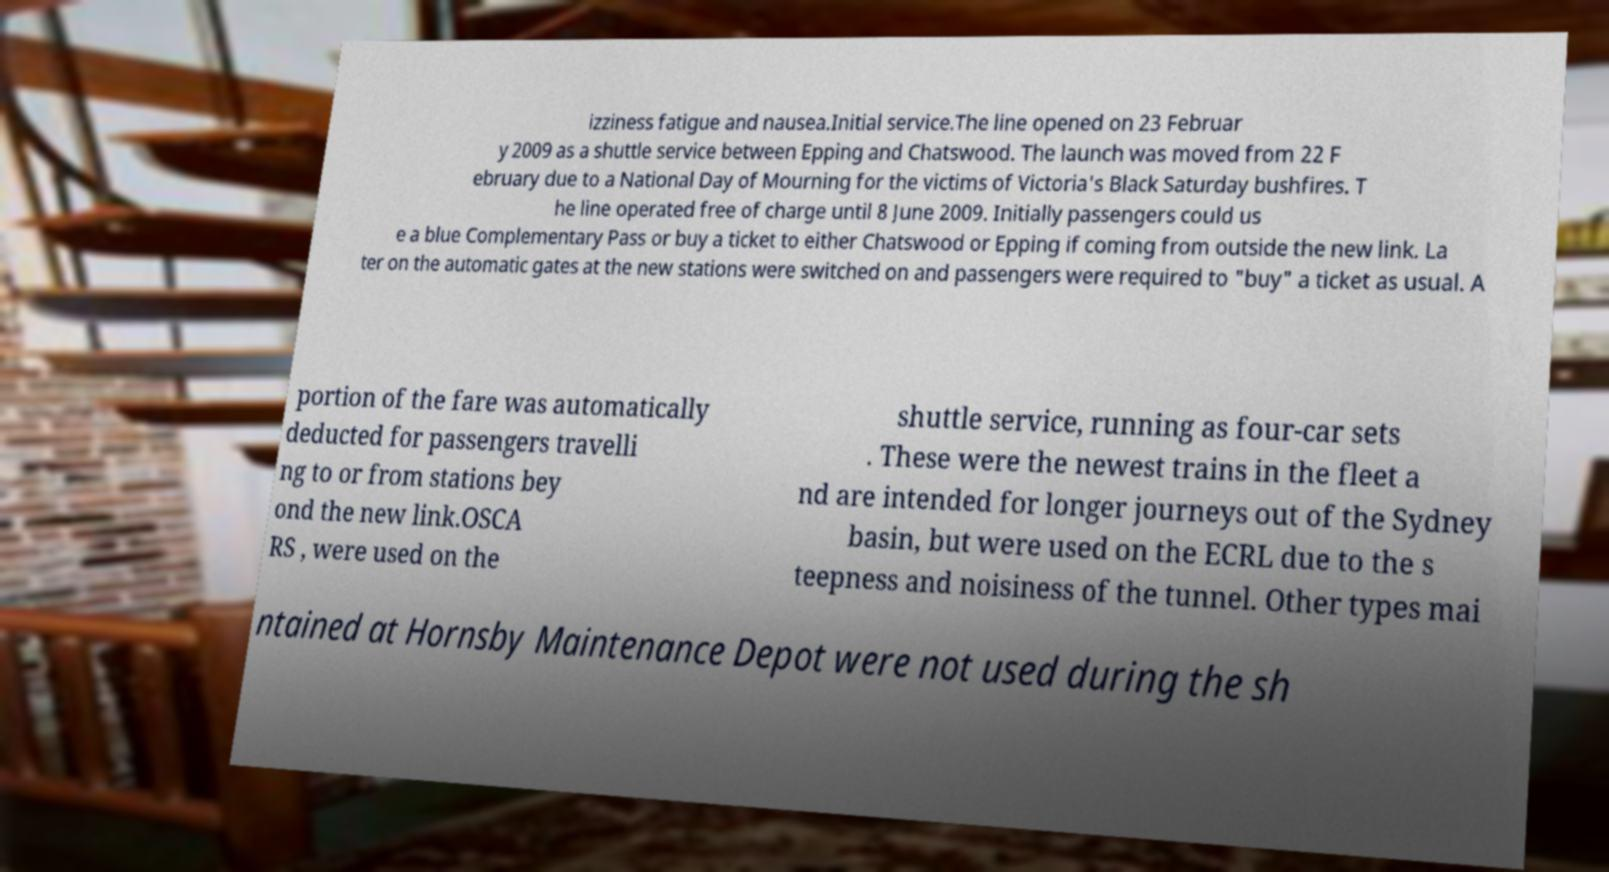Could you assist in decoding the text presented in this image and type it out clearly? izziness fatigue and nausea.Initial service.The line opened on 23 Februar y 2009 as a shuttle service between Epping and Chatswood. The launch was moved from 22 F ebruary due to a National Day of Mourning for the victims of Victoria's Black Saturday bushfires. T he line operated free of charge until 8 June 2009. Initially passengers could us e a blue Complementary Pass or buy a ticket to either Chatswood or Epping if coming from outside the new link. La ter on the automatic gates at the new stations were switched on and passengers were required to "buy" a ticket as usual. A portion of the fare was automatically deducted for passengers travelli ng to or from stations bey ond the new link.OSCA RS , were used on the shuttle service, running as four-car sets . These were the newest trains in the fleet a nd are intended for longer journeys out of the Sydney basin, but were used on the ECRL due to the s teepness and noisiness of the tunnel. Other types mai ntained at Hornsby Maintenance Depot were not used during the sh 